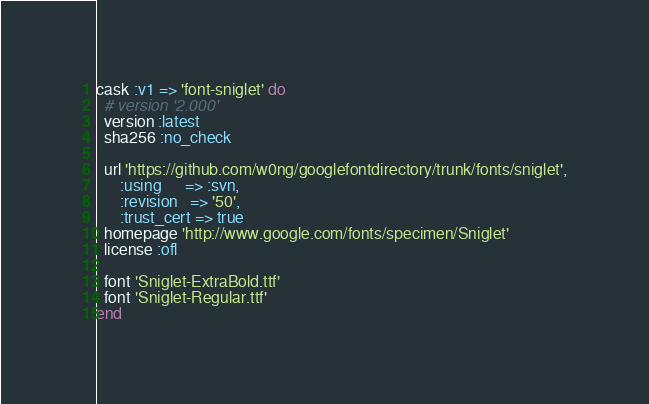Convert code to text. <code><loc_0><loc_0><loc_500><loc_500><_Ruby_>cask :v1 => 'font-sniglet' do
  # version '2.000'
  version :latest
  sha256 :no_check

  url 'https://github.com/w0ng/googlefontdirectory/trunk/fonts/sniglet',
      :using      => :svn,
      :revision   => '50',
      :trust_cert => true
  homepage 'http://www.google.com/fonts/specimen/Sniglet'
  license :ofl

  font 'Sniglet-ExtraBold.ttf'
  font 'Sniglet-Regular.ttf'
end
</code> 